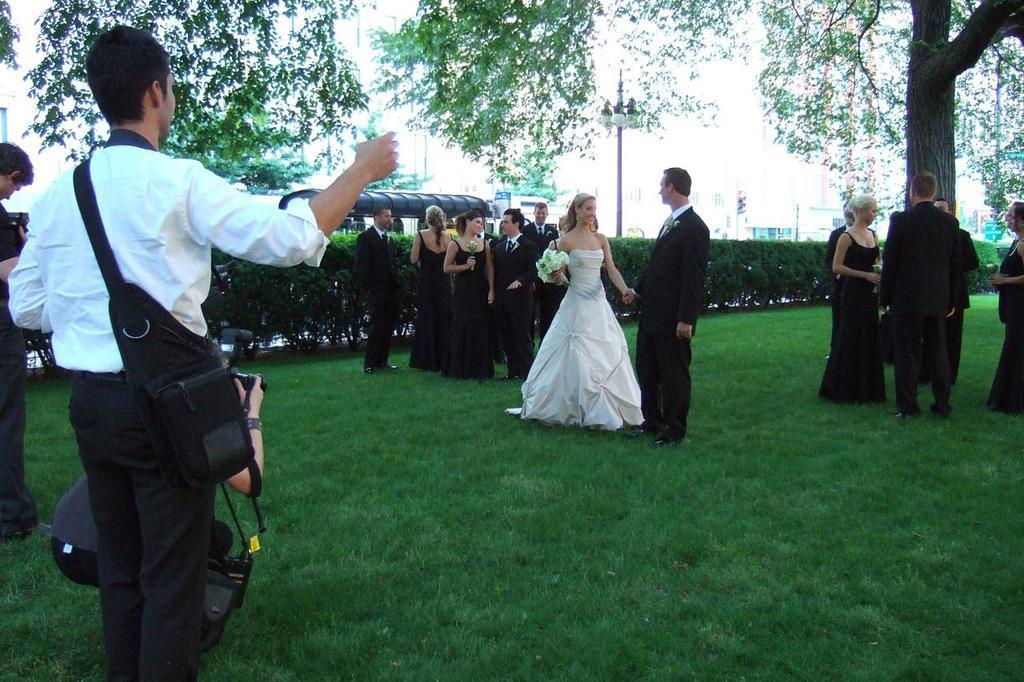Could you give a brief overview of what you see in this image? In this image there is a green grass land and a tree, there is a wedding photo shoot going on, few persons are standing on either side in the middle there is couple posing to a photograph there are three photographer in the left side, in the background there are plants, pole, and a bus. 